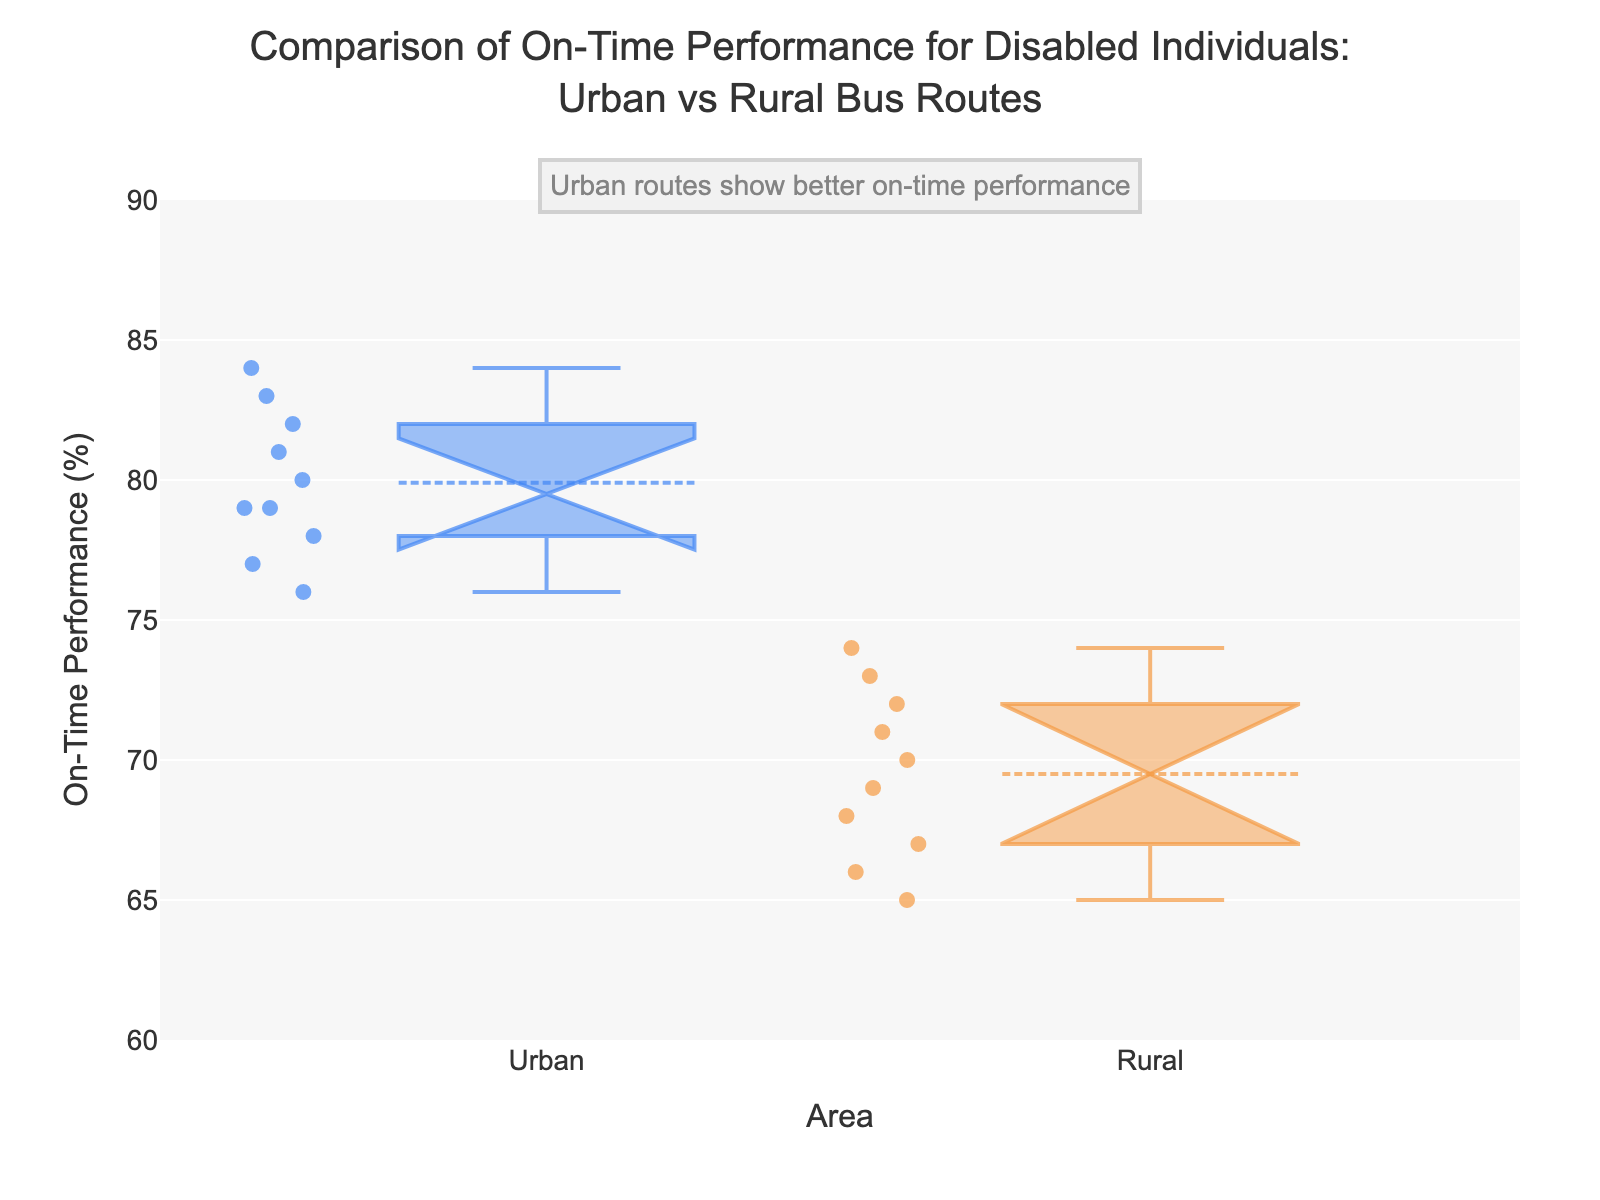What are the two areas compared in the plot? The two areas shown in the plot are Urban and Rural. Urban is represented on the left side of the plot, while Rural is on the right side.
Answer: Urban and Rural What is the title of the plot? The title is located at the top center of the plot and reads "Comparison of On-Time Performance for Disabled Individuals: Urban vs Rural Bus Routes".
Answer: Comparison of On-Time Performance for Disabled Individuals: Urban vs Rural Bus Routes What is the range of the y-axis? The y-axis range is specified on the left of the plot, starting at 60% and going up to 90%.
Answer: 60 to 90 Which area shows better on-time performance for disabled individuals? The plot annotation and the higher median values in the Urban box plot indicate that Urban areas have better on-time performance compared to Rural areas.
Answer: Urban What is the median on-time performance for Urban and Rural areas? The median is the line in the middle of the box. For Urban, it is around 79%, and for Rural, it is approximately 70%.
Answer: Urban: 79%, Rural: 70% Are there any outliers in the Urban data? Outliers are individual points outside the whiskers. In the Urban plot, there are no data points outside the whiskers, indicating no outliers.
Answer: No Is the interquartile range (IQR) larger for Urban or Rural areas? The IQR is represented by the length of the box. The box for Rural areas is taller than that for Urban areas, indicating a larger IQR for Rural areas.
Answer: Rural What do the notches in the boxes signify, and what do they suggest about the medians? Notches in a box plot show the confidence interval around the median. If notches between two boxes do not overlap, it suggests a statistically significant difference between the medians. The notches for Urban and Rural do not overlap, indicating a significant difference.
Answer: Significant difference What is the approximate range of on-time performance for Rural bus routes? The whiskers extend from the minimum to the maximum data points. For Rural areas, the range is from about 65% to 74%.
Answer: 65 to 74 How does the mean on-time performance compare between Urban and Rural areas? The plot includes the mean as a small symbol inside each box. The mean for Urban areas is higher than for Rural areas, reflecting better performance in Urban areas.
Answer: Higher in Urban 